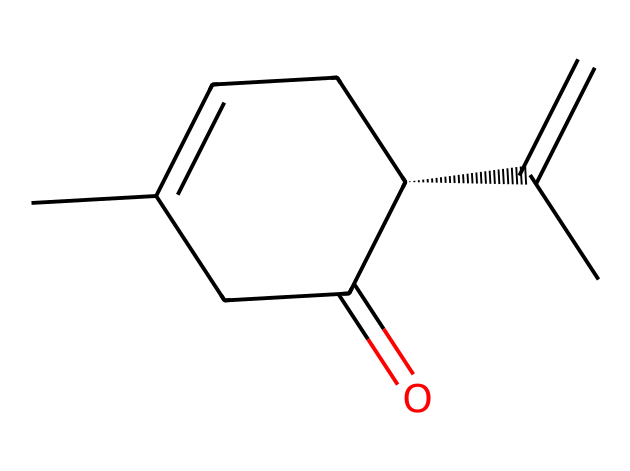What is the molecular formula of carvone? To find the molecular formula, count the number of each type of atom present in the chemical structure. The structure has 10 carbon atoms, 14 hydrogen atoms, and 1 oxygen atom. Therefore, the molecular formula is C10H14O.
Answer: C10H14O How many chiral centers are in carvone? A chiral center is typically a carbon atom that is bonded to four different groups. In the structure, there is one carbon atom (marked in the SMILES as [C@H]) that has four different substituents. Thus, carvone has one chiral center.
Answer: one What type of isomerism does carvone exhibit? Carvone exhibits optical isomerism because it has a chiral center, leading to two enantiomers that are non-superimposable mirror images of each other.
Answer: optical isomerism What is the type of bond between the oxygen and carbon in the carbonyl group of carvone? In the carbonyl group, the bond between the oxygen and carbon is a double bond. This is recognized by the “C(=O)” representation in the SMILES, indicating a carbon double bonded to an oxygen atom.
Answer: double bond What functional group is present in carvone? The presence of a carbonyl group (C=O) in the structure indicates that carvone has a ketone functional group. The carbonyl carbon is connected to two other carbons, which is characteristic of ketones.
Answer: ketone What property of carvone contributes to its characteristic smell? The presence of a specific molecular arrangement, particularly the functional groups and chiral center, influences the volatility and reactivity of the compound, which collectively contributes to its characteristic aroma.
Answer: volatile compounds 